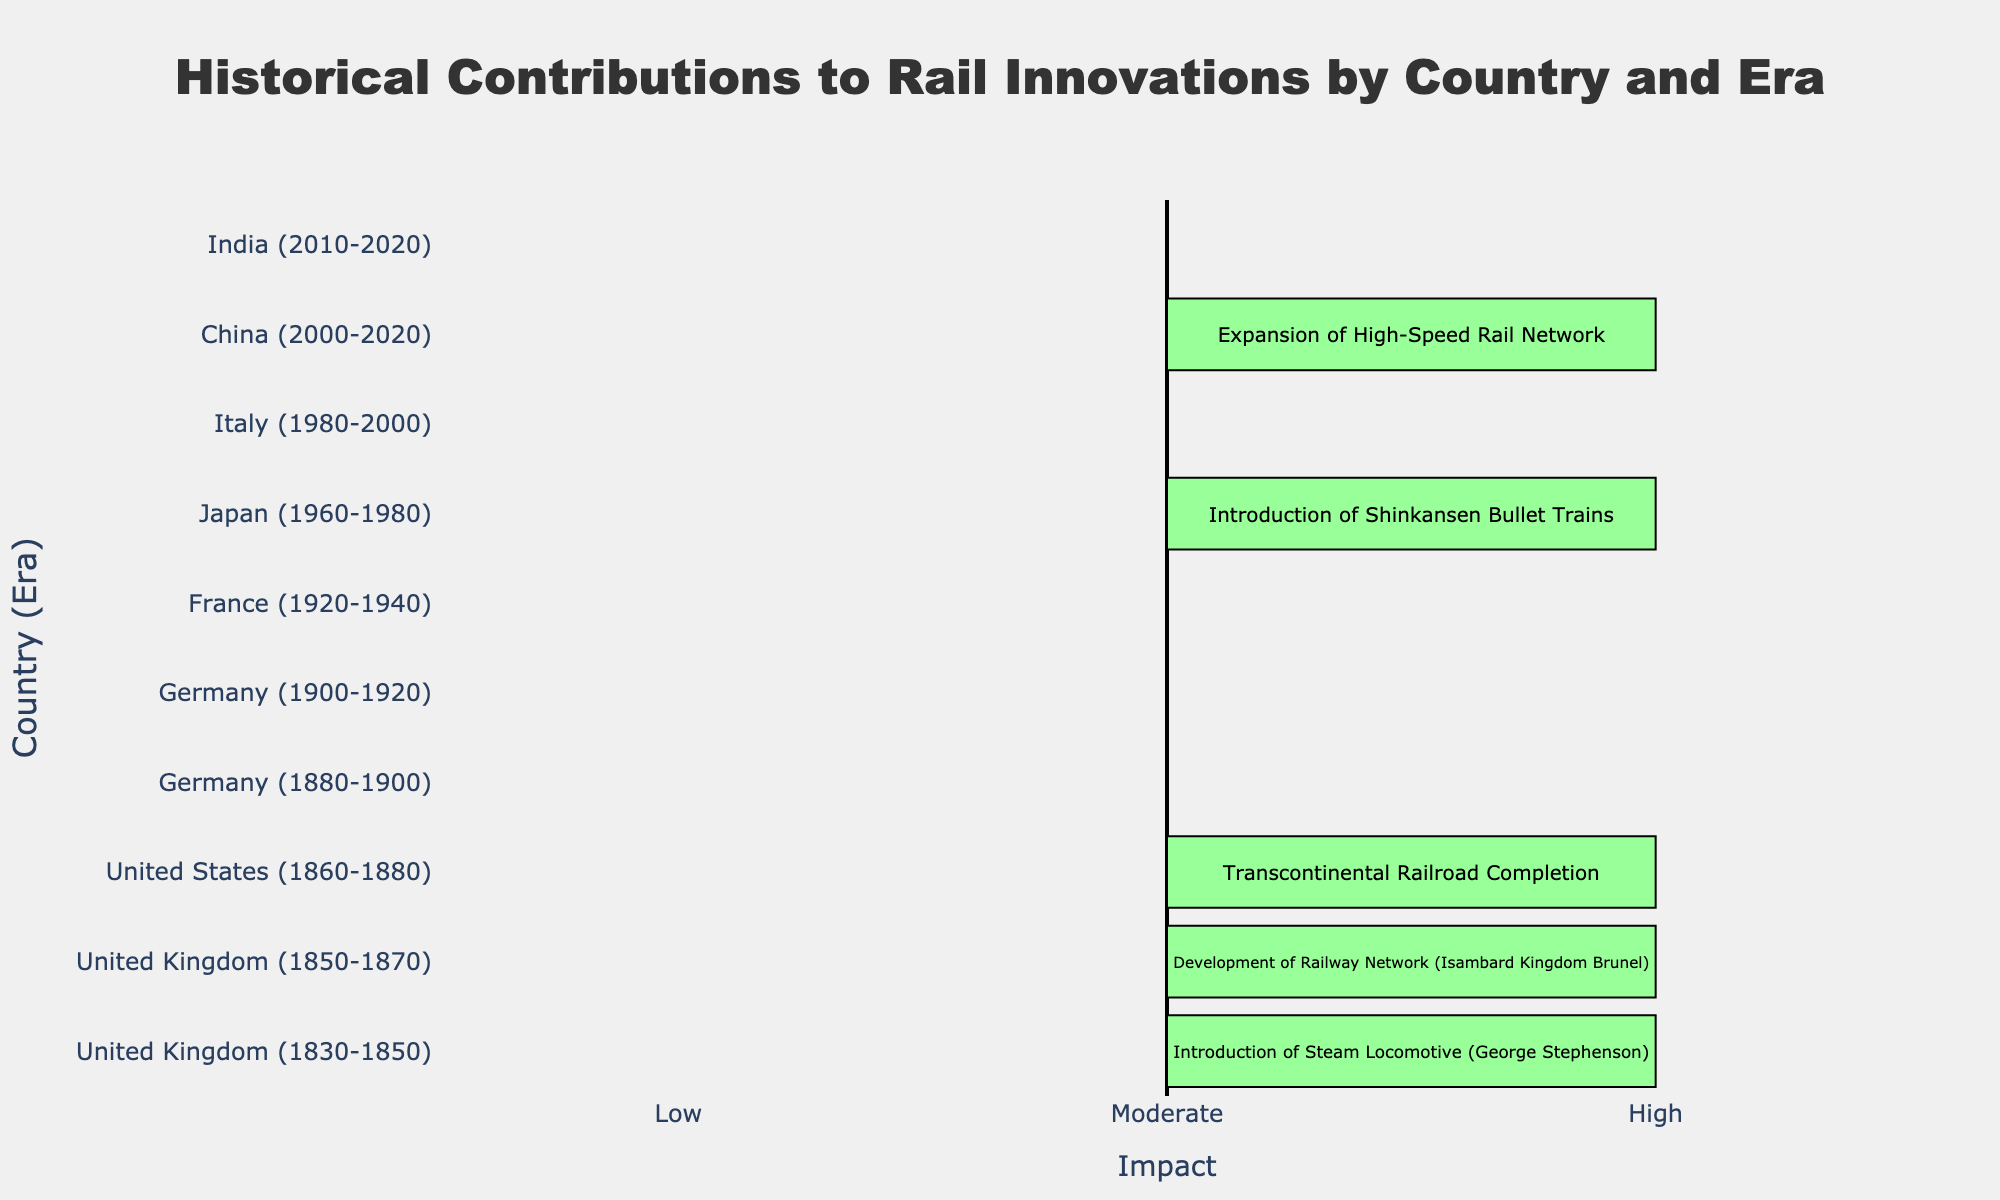Which country has the highest impact on rail innovations during the era 1960-1980? The figure shows that Japan had a "High" impact due to the introduction of Shinkansen Bullet Trains between 1960-1980.
Answer: Japan Which innovations had a "Moderate" impact from 1900 to 1920? The figure shows that Germany had a "Moderate" impact from 1900-1920, with the contribution being the "Standardization of Railway Gauge".
Answer: Standardization of Railway Gauge Compare the contributions of the United Kingdom and the United States in terms of impact. Which has more high-impact innovations? The figure shows two contributions from the UK (1830-1850 and 1850-1870) with high impact and one from the US (1860-1880) with high impact. Therefore, the UK has more high-impact innovations.
Answer: United Kingdom What is the median level of impact for the contributions listed in the chart? There are ten contributions with impact levels: High (x5), Moderate (x5). Sorting these, the middle two values fall between Moderate and High. Thus, the median is Moderate.
Answer: Moderate How many contributions from Asian countries are listed, and what is their impact level? The figure shows contributions from Japan (1960-1980, High), China (2000-2020, High), and India (2010-2020, Moderate), totaling three contributions.
Answer: Three contributions: two High, one Moderate What contribution is associated with the longest lasting era shown in the chart? The longest era listed (20 years) is from Italy (1980-2000), contributing the development of Pendolino tilting trains with a "Moderate" impact.
Answer: Development of Pendolino tilting trains Which era saw the introduction of electric locomotives, and what country was responsible? The figure shows that electric locomotives were introduced by Germany from 1880-1900, with a "Moderate" impact.
Answer: 1880-1900, Germany By comparing the colors of the bars in the diverging bar chart, which colors correspond to high and moderate impacts, respectively? The figure uses a green shade for high impact and a yellow shade for moderate impact.
Answer: Green for High, Yellow for Moderate 